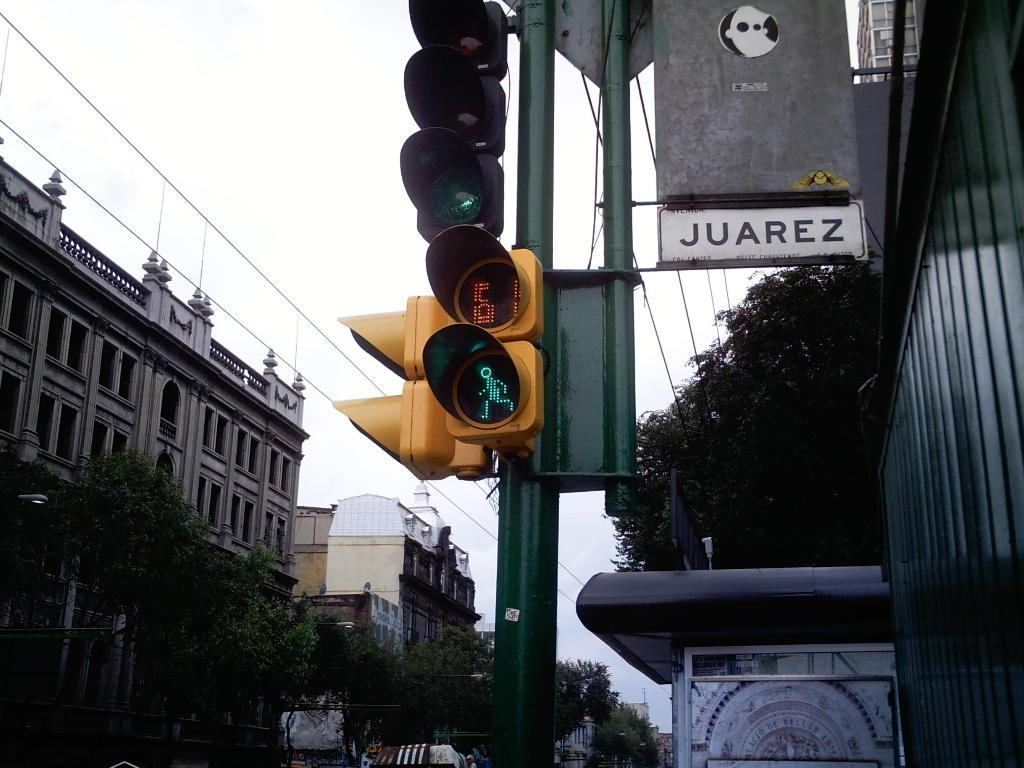<image>
Write a terse but informative summary of the picture. Juarez has crosswalks that give people time to pass. 